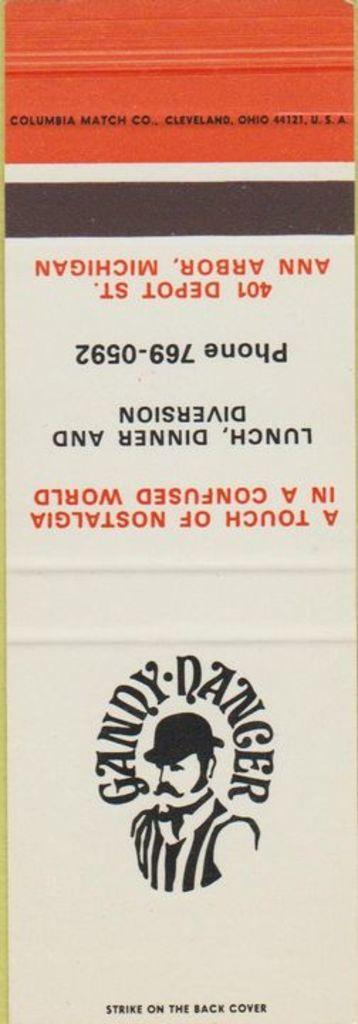Please provide a concise description of this image. In this image, we can see a poster with some image and text written. 